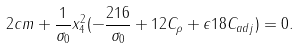Convert formula to latex. <formula><loc_0><loc_0><loc_500><loc_500>2 c m + \frac { 1 } { \sigma _ { 0 } } x _ { 4 } ^ { 2 } ( - \frac { 2 1 6 } { \sigma _ { 0 } } + 1 2 C _ { \rho } + \epsilon 1 8 C _ { a d j } ) = 0 .</formula> 